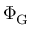Convert formula to latex. <formula><loc_0><loc_0><loc_500><loc_500>\Phi _ { G }</formula> 